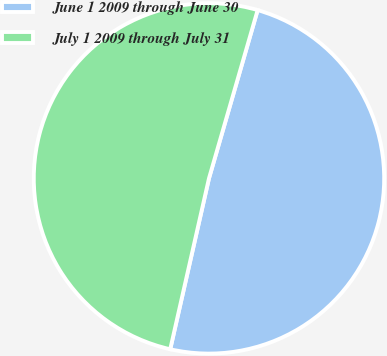<chart> <loc_0><loc_0><loc_500><loc_500><pie_chart><fcel>June 1 2009 through June 30<fcel>July 1 2009 through July 31<nl><fcel>49.07%<fcel>50.93%<nl></chart> 